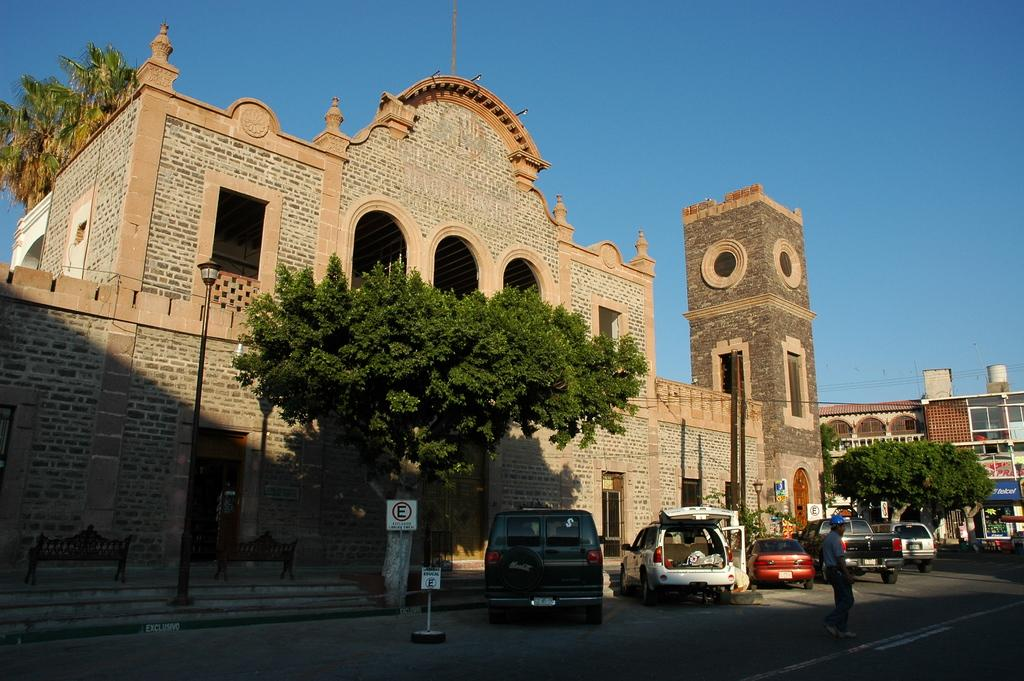Who is present in the image? There is a man in the image. What can be seen on the road in the image? There are vehicles on the road in the image. What type of furniture is on the floor in the image? There are benches on the floor in the image. What type of vegetation is in the image? There are trees in the image. What type of structures are in the image? There are poles and buildings in the image. What type of information is displayed in the image? There are sign boards in the image. What other objects can be seen in the image? There are some objects in the image. What is visible in the background of the image? The sky is visible in the background of the image. Can you tell me how many snakes are slithering on the man's shoulder in the image? There are no snakes present in the image; the man is not interacting with any snakes. 